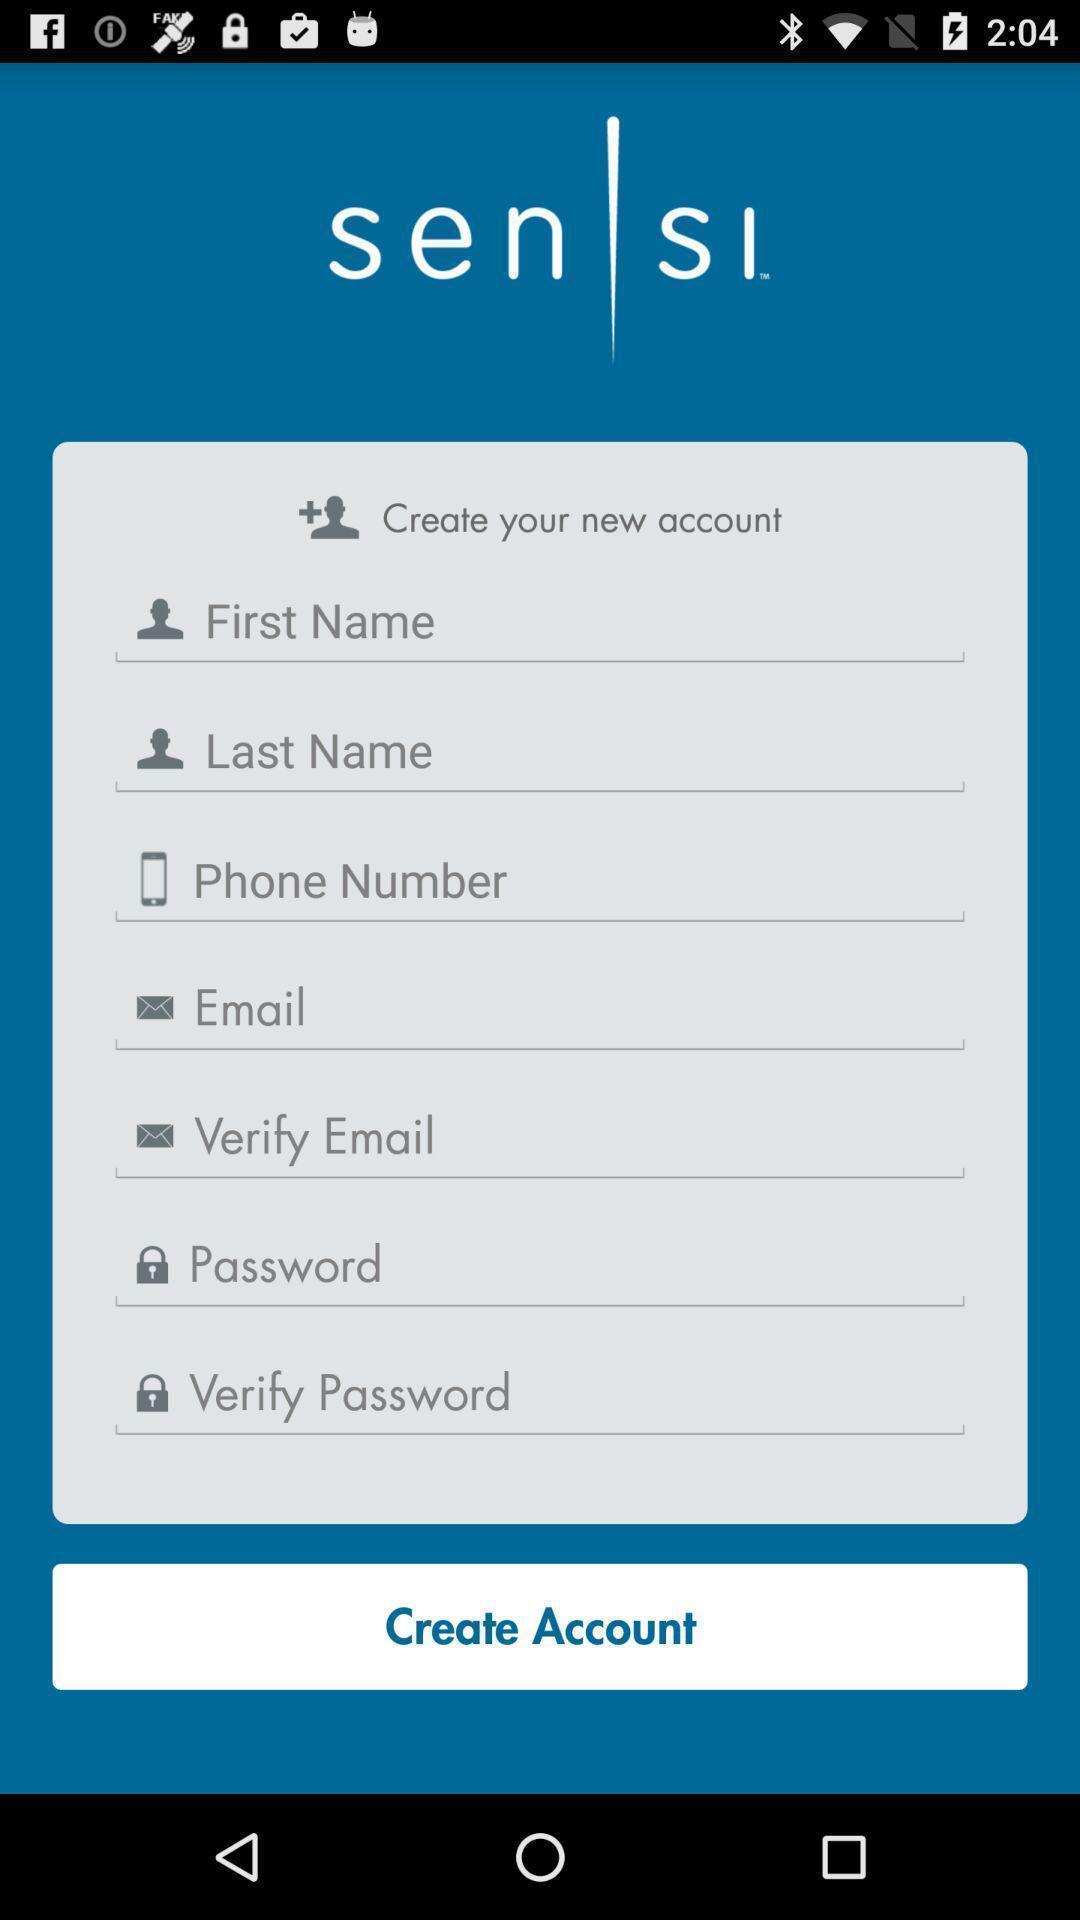Describe this image in words. Screen displaying multiple options in account registration page. 